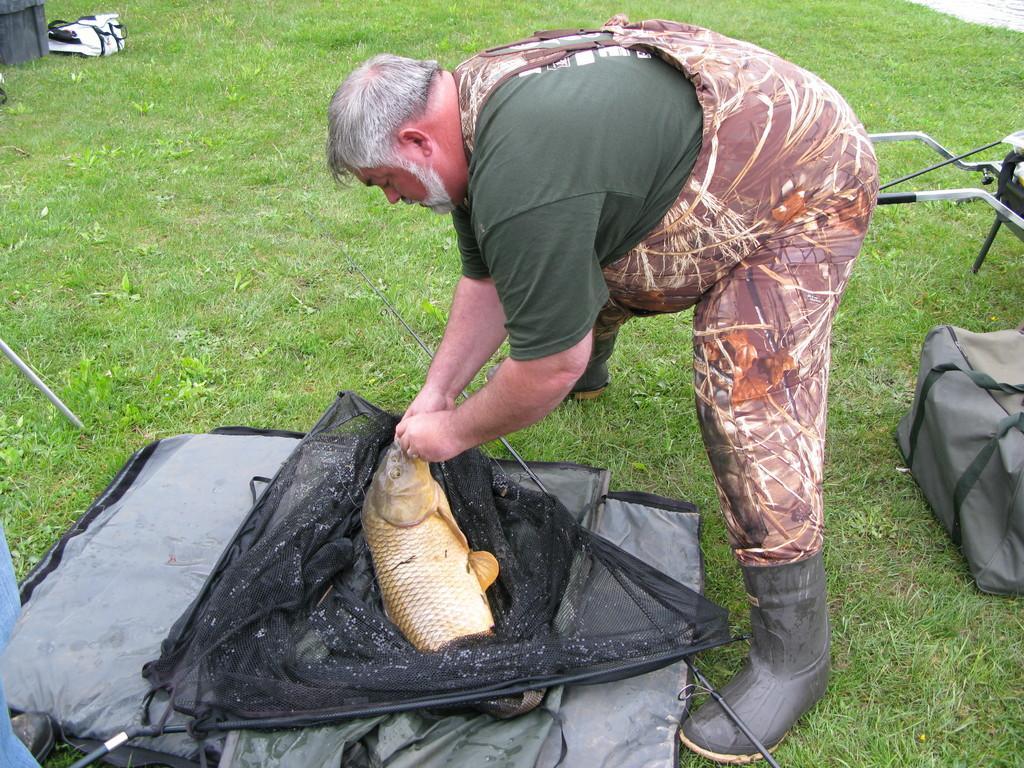Could you give a brief overview of what you see in this image? This image consists of a man holding a fish. At the bottom, we can see a mat and a net. On the right, there is a bag. At the bottom, there is green grass. In the top left, there is a bag in white color. 